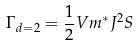Convert formula to latex. <formula><loc_0><loc_0><loc_500><loc_500>\Gamma _ { d = 2 } = \frac { 1 } { 2 } V m ^ { * } J ^ { 2 } S</formula> 